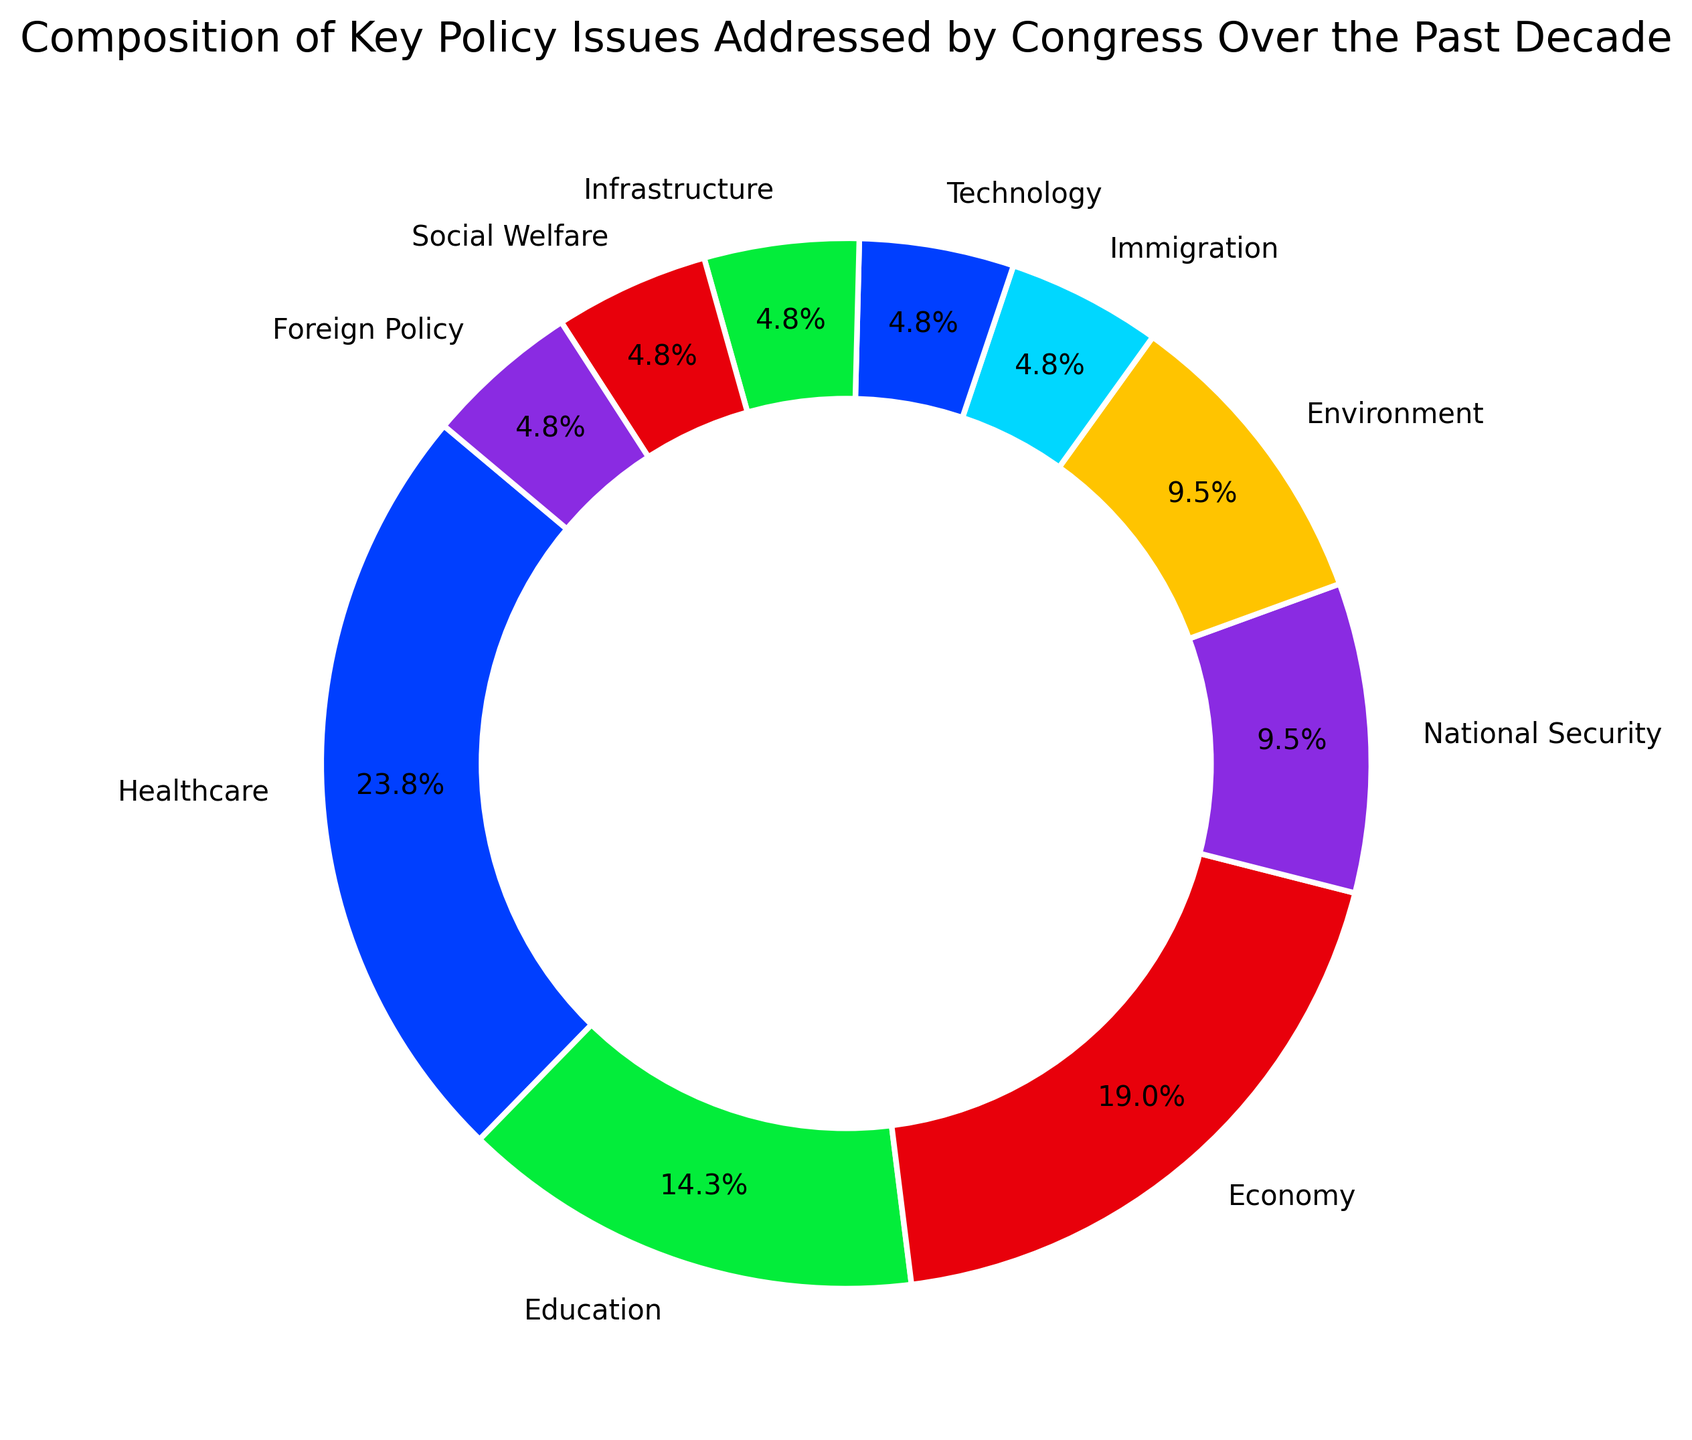Which policy issue received the highest percentage of attention? The figure shows multiple segments for each policy issue with their respective percentages. The largest segment represents the policy issue with the highest percentage.
Answer: Healthcare How much more attention did Healthcare receive compared to National Security? The percentage for Healthcare is 25%, while for National Security it is 10%. Subtract the percentage for National Security from Healthcare to find the difference: 25% - 10% = 15%.
Answer: 15% What's the combined percentage of attention given to Education and Environment? The figure shows that Education received 15% and Environment received 10%. To combine these, add the two percentages together: 15% + 10% = 25%.
Answer: 25% Which policy issues received equal percentages of attention? From the figure, you can identify that Immigration, Technology, Infrastructure, Social Welfare, and Foreign Policy each received 5%.
Answer: Immigration, Technology, Infrastructure, Social Welfare, Foreign Policy How does the attention given to the Economy compare to that of Social Welfare? The Economy is represented by 20% of the attention, while Social Welfare has 5%. Comparing these, the Economy received significantly more attention.
Answer: Economy received more What is the average percentage of attention given to Technology, Infrastructure, and Social Welfare? The percentages for Technology, Infrastructure, and Social Welfare are each 5%. Add these together and divide by the number of policy issues to get the average: (5% + 5% + 5%) / 3 = 5%.
Answer: 5% What is the total percentage of all the policy issues represented in the figure? Since the figure represents the entire composition of policy issues, the total percentage adds up to 100%.
Answer: 100% Which policy issues together make up 50% of the total attention? By examining the figure, you can combine Healthcare (25%), Education (15%), and National Security (10%) to get a total of 50%.
Answer: Healthcare and Education and National Security Is there any two policy issues whose combined attention equals to that of Healthcare? Yes, Education (15%) and Economy (20%) together make 35%, which is not equal to Healthcare. However, National Security (10%) and Economy (20%) together make 30%, which is still not equal. Thus, no two policy issues' combined attention equals that of Healthcare (25%).
Answer: No Arrange the policy issues in descending order of attention received. From the figure, list them in order from highest to lowest: Healthcare (25%), Economy (20%), Education (15%), National Security (10%), Environment (10%), and then Immigration, Technology, Infrastructure, Social Welfare, Foreign Policy (each 5%).
Answer: Healthcare, Economy, Education, National Security, Environment, Immigration, Technology, Infrastructure, Social Welfare, Foreign Policy 